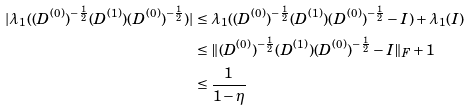<formula> <loc_0><loc_0><loc_500><loc_500>| \lambda _ { 1 } ( ( D ^ { ( 0 ) } ) ^ { - \frac { 1 } { 2 } } ( D ^ { ( 1 ) } ) ( D ^ { ( 0 ) } ) ^ { - \frac { 1 } { 2 } } ) | & \leq \lambda _ { 1 } ( ( D ^ { ( 0 ) } ) ^ { - \frac { 1 } { 2 } } ( D ^ { ( 1 ) } ) ( D ^ { ( 0 ) } ) ^ { - \frac { 1 } { 2 } } - I ) + \lambda _ { 1 } ( I ) \\ & \leq \| ( D ^ { ( 0 ) } ) ^ { - \frac { 1 } { 2 } } ( D ^ { ( 1 ) } ) ( D ^ { ( 0 ) } ) ^ { - \frac { 1 } { 2 } } - I \| _ { F } + 1 \\ & \leq \frac { 1 } { 1 - \eta }</formula> 